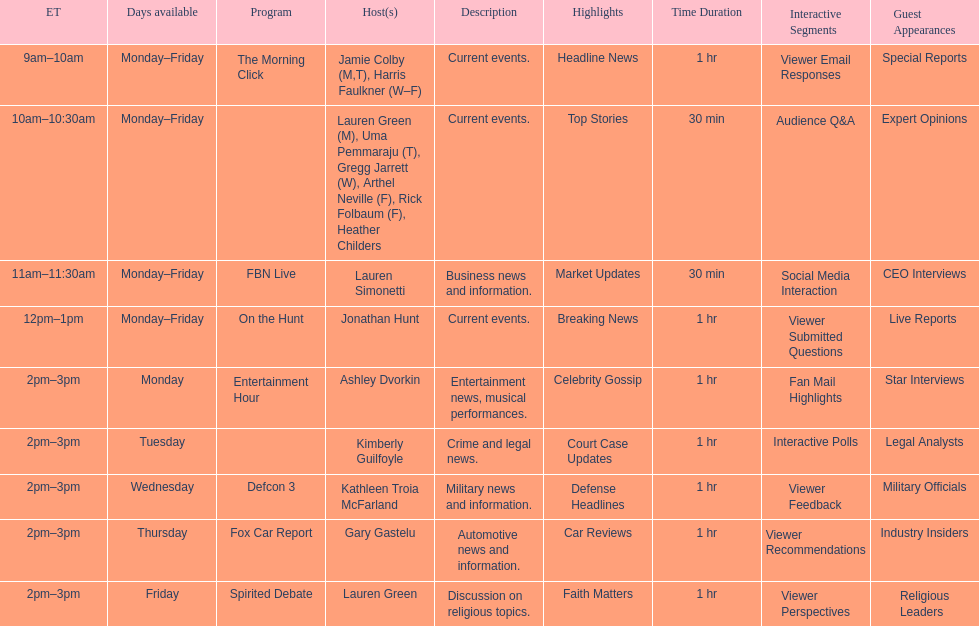How many days is fbn live available each week? 5. 